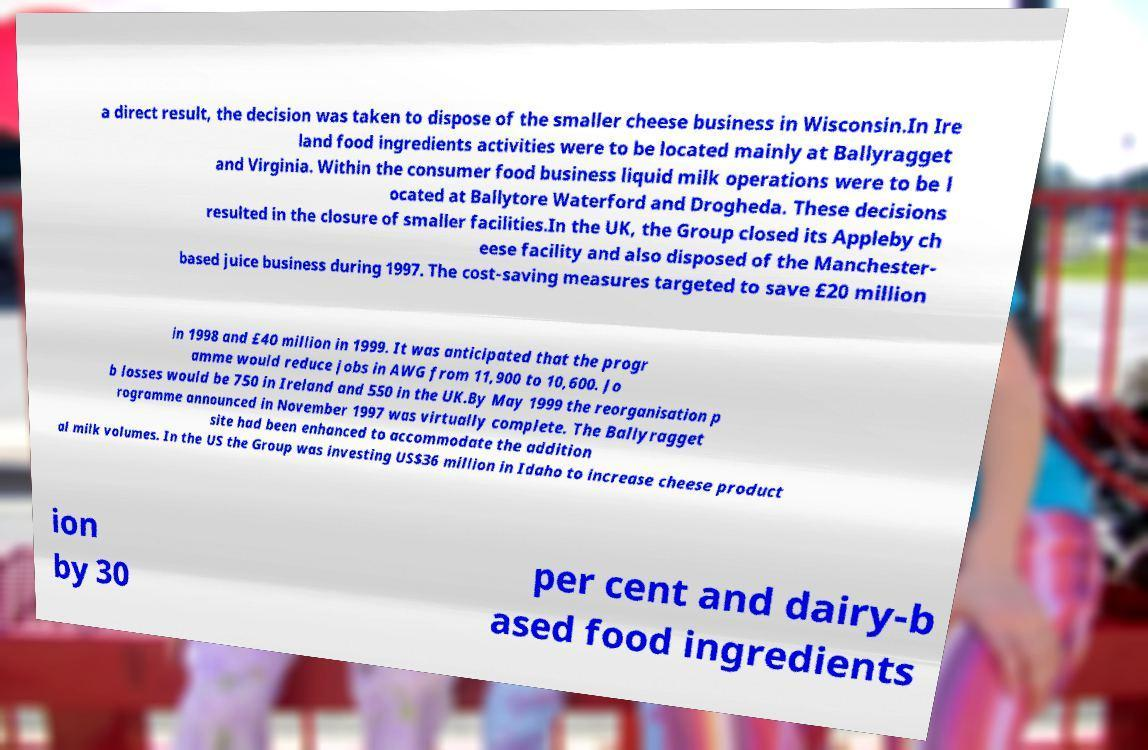I need the written content from this picture converted into text. Can you do that? a direct result, the decision was taken to dispose of the smaller cheese business in Wisconsin.In Ire land food ingredients activities were to be located mainly at Ballyragget and Virginia. Within the consumer food business liquid milk operations were to be l ocated at Ballytore Waterford and Drogheda. These decisions resulted in the closure of smaller facilities.In the UK, the Group closed its Appleby ch eese facility and also disposed of the Manchester- based juice business during 1997. The cost-saving measures targeted to save £20 million in 1998 and £40 million in 1999. It was anticipated that the progr amme would reduce jobs in AWG from 11,900 to 10,600. Jo b losses would be 750 in Ireland and 550 in the UK.By May 1999 the reorganisation p rogramme announced in November 1997 was virtually complete. The Ballyragget site had been enhanced to accommodate the addition al milk volumes. In the US the Group was investing US$36 million in Idaho to increase cheese product ion by 30 per cent and dairy-b ased food ingredients 